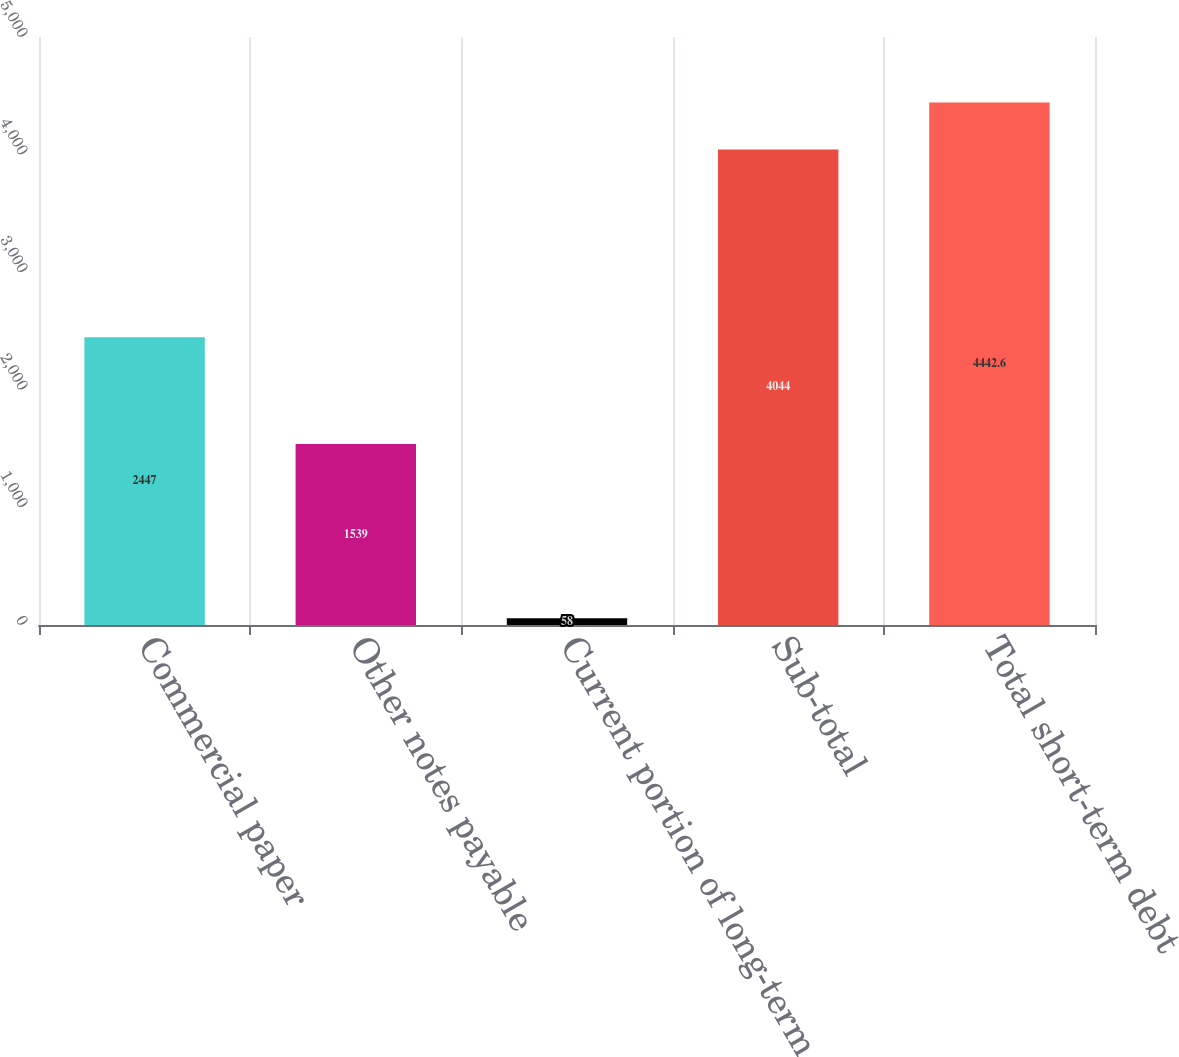Convert chart to OTSL. <chart><loc_0><loc_0><loc_500><loc_500><bar_chart><fcel>Commercial paper<fcel>Other notes payable<fcel>Current portion of long-term<fcel>Sub-total<fcel>Total short-term debt<nl><fcel>2447<fcel>1539<fcel>58<fcel>4044<fcel>4442.6<nl></chart> 